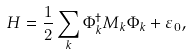<formula> <loc_0><loc_0><loc_500><loc_500>H = \frac { 1 } { 2 } \sum _ { k } \Phi _ { k } ^ { \dagger } M _ { k } \Phi _ { k } + \varepsilon _ { 0 } ,</formula> 